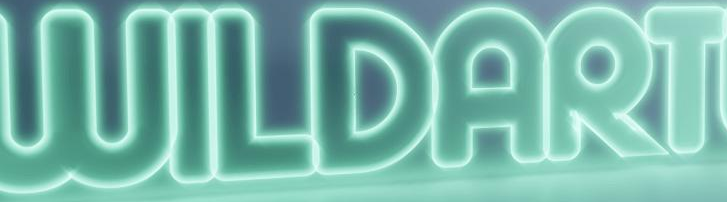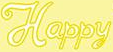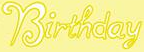Identify the words shown in these images in order, separated by a semicolon. WILDART; Happy; Birthday 